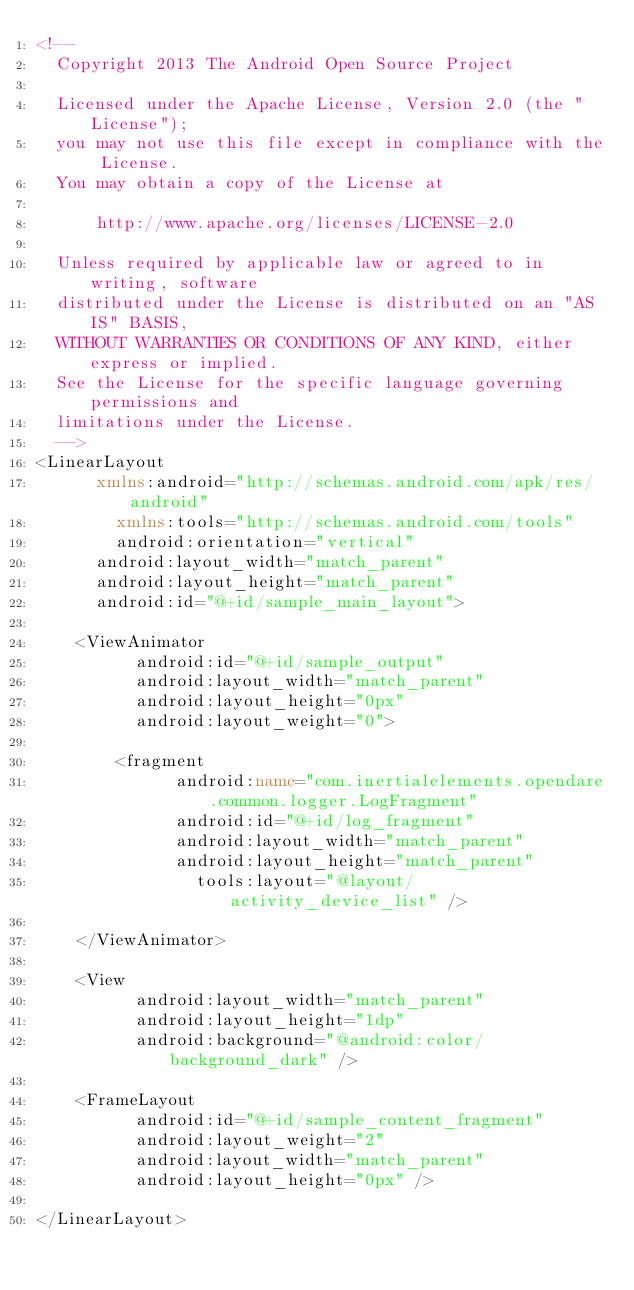Convert code to text. <code><loc_0><loc_0><loc_500><loc_500><_XML_><!--
  Copyright 2013 The Android Open Source Project

  Licensed under the Apache License, Version 2.0 (the "License");
  you may not use this file except in compliance with the License.
  You may obtain a copy of the License at

      http://www.apache.org/licenses/LICENSE-2.0

  Unless required by applicable law or agreed to in writing, software
  distributed under the License is distributed on an "AS IS" BASIS,
  WITHOUT WARRANTIES OR CONDITIONS OF ANY KIND, either express or implied.
  See the License for the specific language governing permissions and
  limitations under the License.
  -->
<LinearLayout
      xmlns:android="http://schemas.android.com/apk/res/android"
        xmlns:tools="http://schemas.android.com/tools"
        android:orientation="vertical"
      android:layout_width="match_parent"
      android:layout_height="match_parent"
      android:id="@+id/sample_main_layout">

    <ViewAnimator
          android:id="@+id/sample_output"
          android:layout_width="match_parent"
          android:layout_height="0px"
          android:layout_weight="0">

        <fragment
              android:name="com.inertialelements.opendare.common.logger.LogFragment"
              android:id="@+id/log_fragment"
              android:layout_width="match_parent"
              android:layout_height="match_parent"
                tools:layout="@layout/activity_device_list" />

    </ViewAnimator>

    <View
          android:layout_width="match_parent"
          android:layout_height="1dp"
          android:background="@android:color/background_dark" />

    <FrameLayout
          android:id="@+id/sample_content_fragment"
          android:layout_weight="2"
          android:layout_width="match_parent"
          android:layout_height="0px" />

</LinearLayout>

</code> 